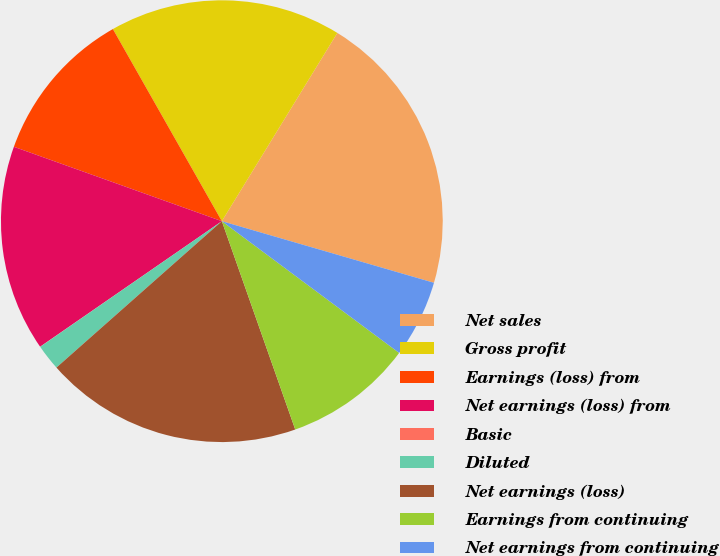<chart> <loc_0><loc_0><loc_500><loc_500><pie_chart><fcel>Net sales<fcel>Gross profit<fcel>Earnings (loss) from<fcel>Net earnings (loss) from<fcel>Basic<fcel>Diluted<fcel>Net earnings (loss)<fcel>Earnings from continuing<fcel>Net earnings from continuing<nl><fcel>20.74%<fcel>16.97%<fcel>11.32%<fcel>15.09%<fcel>0.01%<fcel>1.9%<fcel>18.86%<fcel>9.44%<fcel>5.67%<nl></chart> 